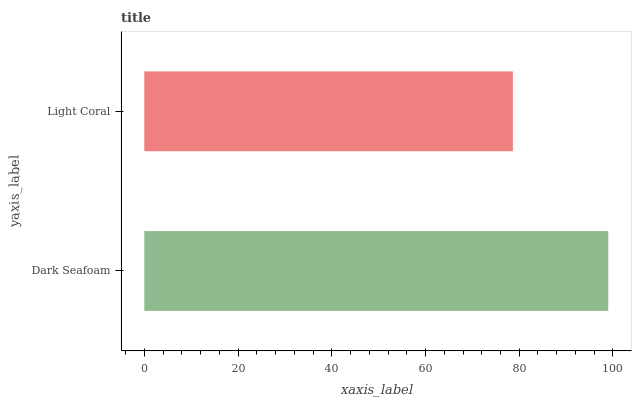Is Light Coral the minimum?
Answer yes or no. Yes. Is Dark Seafoam the maximum?
Answer yes or no. Yes. Is Light Coral the maximum?
Answer yes or no. No. Is Dark Seafoam greater than Light Coral?
Answer yes or no. Yes. Is Light Coral less than Dark Seafoam?
Answer yes or no. Yes. Is Light Coral greater than Dark Seafoam?
Answer yes or no. No. Is Dark Seafoam less than Light Coral?
Answer yes or no. No. Is Dark Seafoam the high median?
Answer yes or no. Yes. Is Light Coral the low median?
Answer yes or no. Yes. Is Light Coral the high median?
Answer yes or no. No. Is Dark Seafoam the low median?
Answer yes or no. No. 